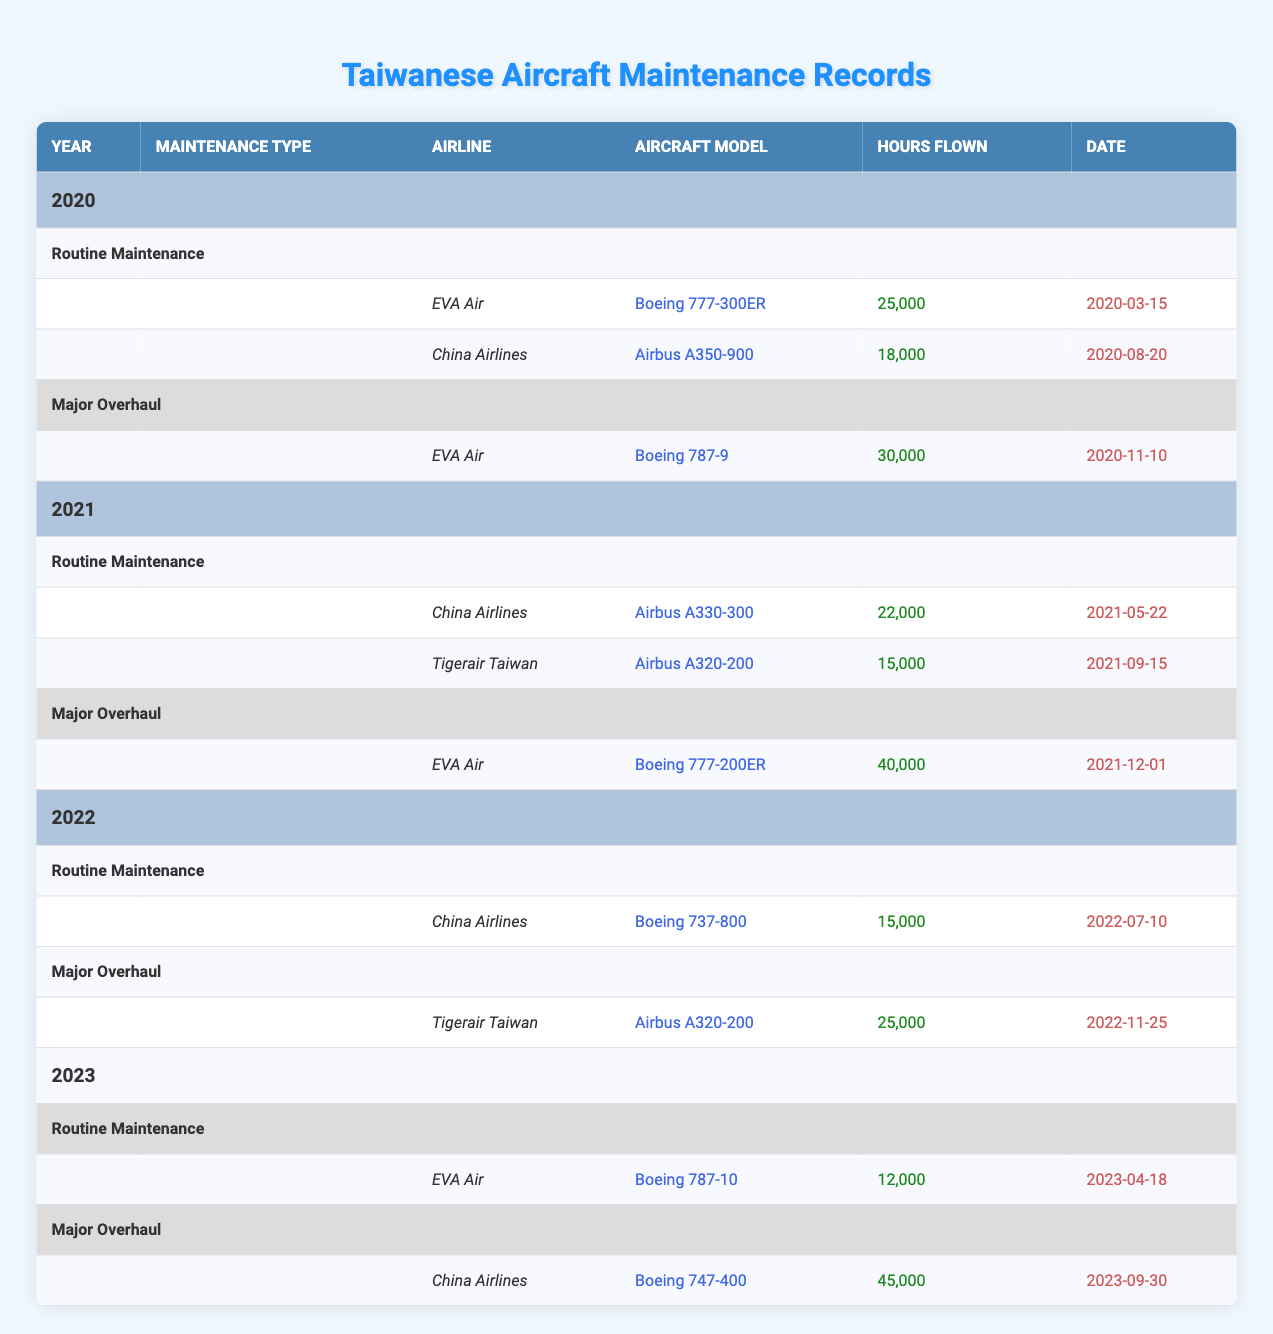What types of aircraft underwent Routine Maintenance in 2021? In 2021, the two airlines that conducted Routine Maintenance were China Airlines and Tigerair Taiwan. The specific aircraft models were Airbus A330-300 for China Airlines and Airbus A320-200 for Tigerair Taiwan.
Answer: Airbus A330-300, Airbus A320-200 Which aircraft had the highest Hours Flown in 2020? Looking at the Routine Maintenance and Major Overhaul records for 2020, EVA Air's Boeing 787-9 had 30,000 hours flown, which is the highest recorded in that year.
Answer: Boeing 787-9 (30,000 hours) Was there any Routine Maintenance done in 2023? Yes, Routine Maintenance was performed by EVA Air on a Boeing 787-10 in 2023.
Answer: Yes What is the total number of Hours Flown for all Major Overhauls in 2022? There was one Major Overhaul in 2022 by Tigerair Taiwan with 25,000 hours flown. Adding that to the one recorded in the previous year, 40,000 hours from EVA Air's Major Overhaul in 2021, the total is 25,000 + 40,000 = 65,000 hours.
Answer: 65,000 hours How many different aircraft models underwent Major Overhaul maintenance in 2021? In 2021, only one Major Overhaul was reported, and it was for EVA Air's Boeing 777-200ER. Therefore, there was only one unique aircraft model that underwent Major Overhaul maintenance.
Answer: 1 model What aircraft model had the least Hours Flown in 2022? The only Routine Maintenance recorded in 2022 was for China Airlines' Boeing 737-800, which had 15,000 hours flown. For Major Overhaul, Tigerair Taiwan's Airbus A320-200 had 25,000 hours flown. Therefore, the Boeing 737-800 had the least at 15,000 hours.
Answer: Boeing 737-800 (15,000 hours) How many times did EVA Air perform maintenance across all years? EVA Air performed maintenance four times, with two Routine Maintenance sessions in 2020 and 2023, and two Major Overhauls in 2020 and 2021.
Answer: 4 times Which airline performed Major Overhaul in 2023 and what aircraft model was it? In 2023, China Airlines performed a Major Overhaul on a Boeing 747-400.
Answer: China Airlines, Boeing 747-400 